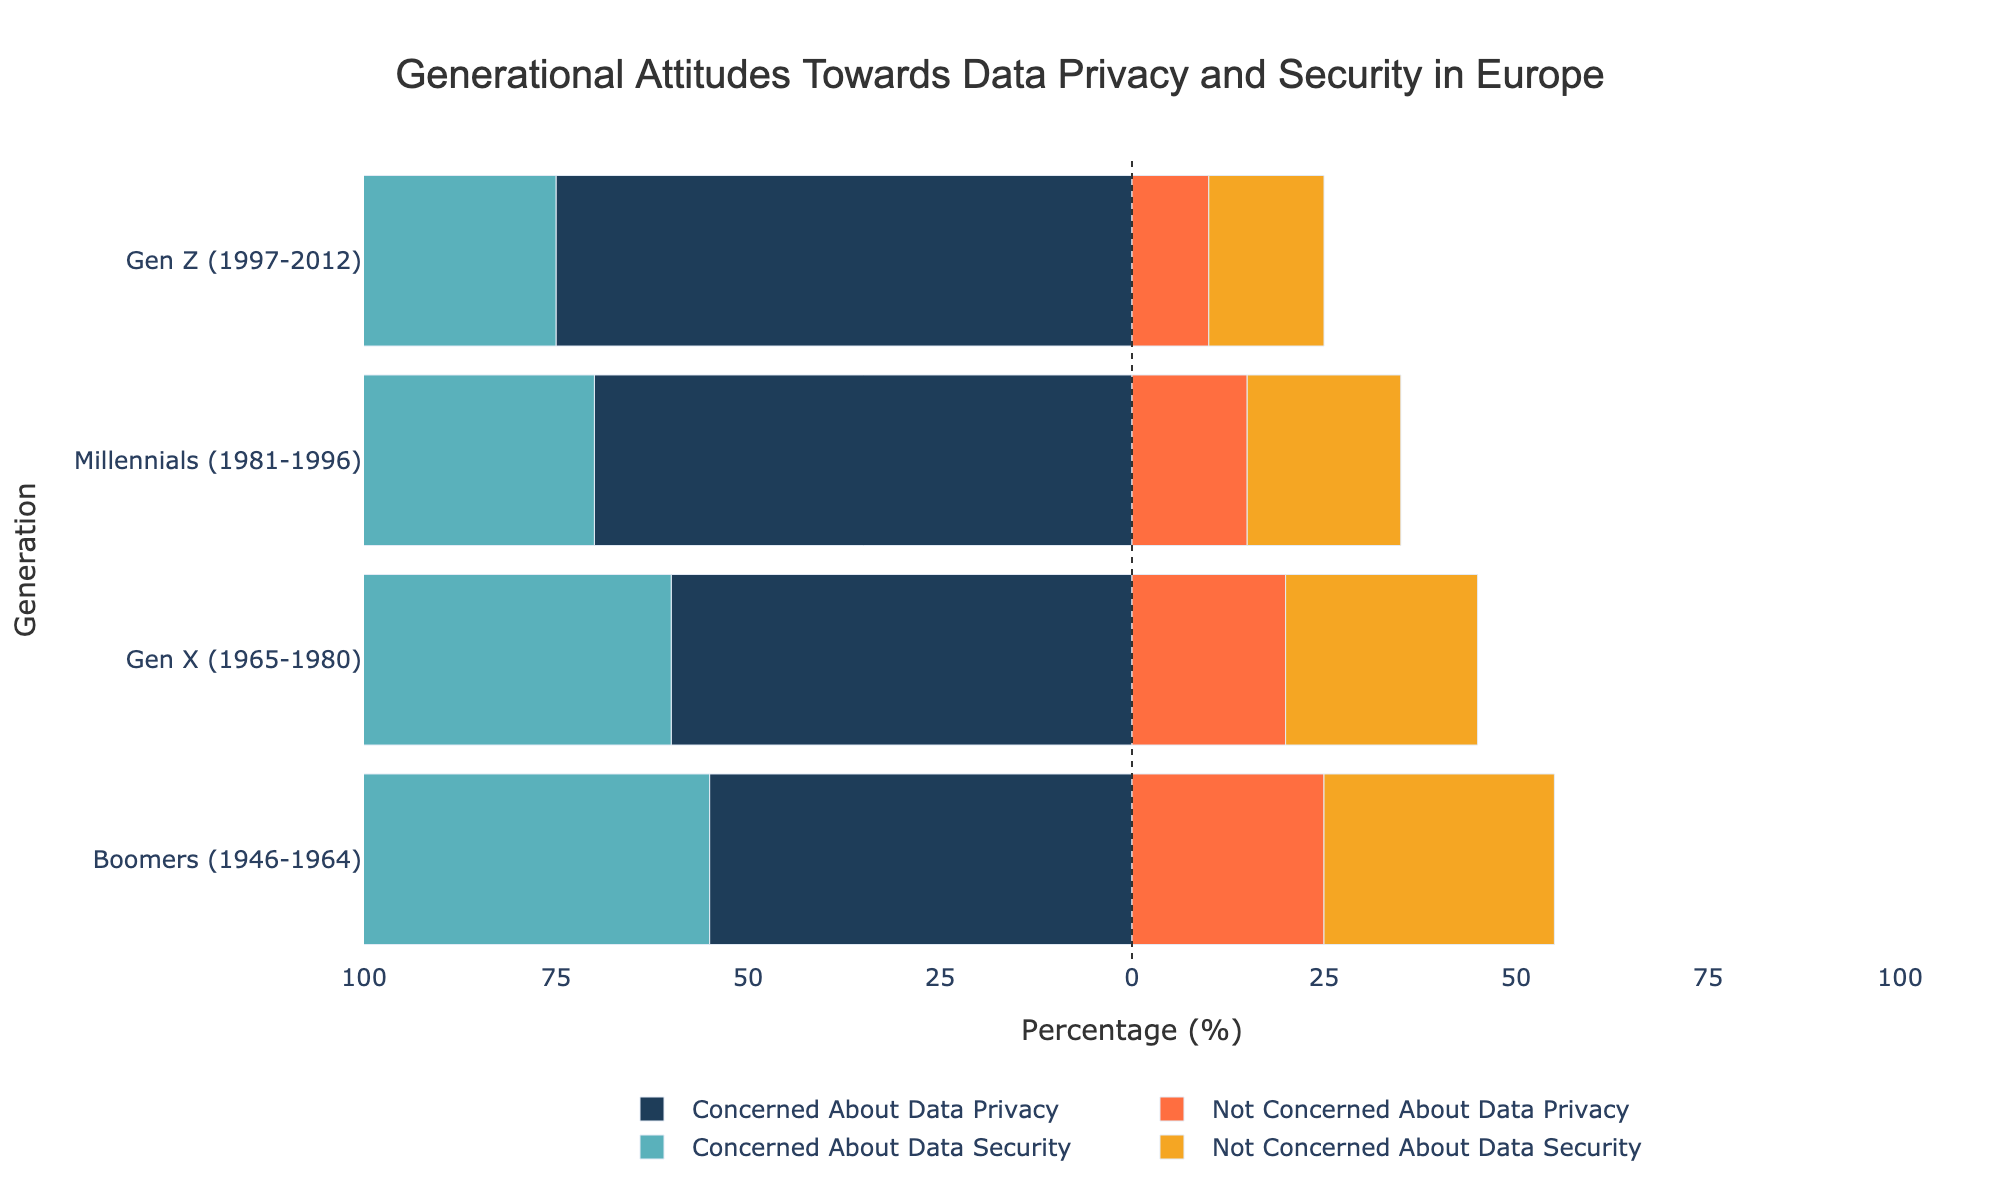How do Millennials compare to Gen X in terms of concern about data privacy? The bar for Millennials concerned about data privacy is longer than the bar for Gen X. Millennials have 70% concerned compared to 60% for Gen X.
Answer: Millennials are more concerned What is the difference between Gen Z and Boomers regarding concern about data security? Gen Z has 80% concerned about data security, while Boomers have 65%. The difference is 80 - 65 = 15.
Answer: 15% Which generation has the least percentage of people not concerned about data privacy? The bar for not concerned about data privacy is shortest for Gen Z, with 10%.
Answer: Gen Z What's the total percentage of Gen X either concerned or not concerned about data security? Gen X has 70% concerned and 25% not concerned, so the total is 70 + 25 = 95.
Answer: 95% What is the ratio of Millennials concerned about data privacy to those not concerned? Millennials have 70% concerned and 15% not concerned. The ratio is 70:15, which simplifies to 14:3.
Answer: 14:3 How does the percentage of Boomers not concerned about data security compare to Millennials not concerned about data security? Boomers have 30% not concerned about data security and Millennials have 20%. 30% is greater than 20%.
Answer: Boomers have a higher percentage Which has a higher percentage, Gen Z concerned about data security or Millennials concerned about data privacy? Gen Z has 80% concerned about data security and Millennials have 70% concerned about data privacy. 80% is higher than 70%.
Answer: Gen Z What’s the combined percentage of people in Gen X not concerned about data privacy and security? Gen X has 20% not concerned about privacy and 25% not concerned about security. The combined percentage is 20 + 25 = 45.
Answer: 45% By how much does the percentage of Boomers concerned about data security exceed those not concerned about data security? Boomers have 65% concerned and 30% not concerned. The difference is 65 - 30 = 35.
Answer: 35% Which generation shows the highest concern for data security? The bar for concern about data security is longest for Gen Z with 80%.
Answer: Gen Z 